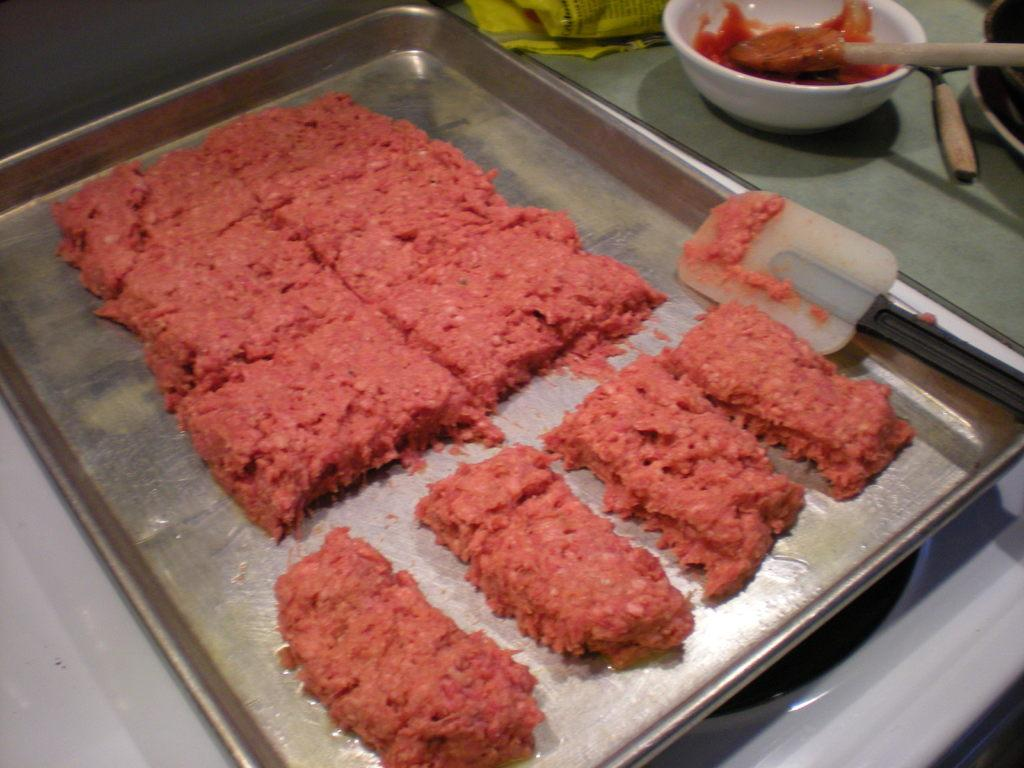What is the color of the tray in the image? The tray in the image is silver in color. What is placed on the tray? There is a bowl on the tray. What utensils can be seen on the surface in the image? There are spatulas on the surface in the image. How much coal is present on the tray in the image? There is no coal present on the tray in the image. 